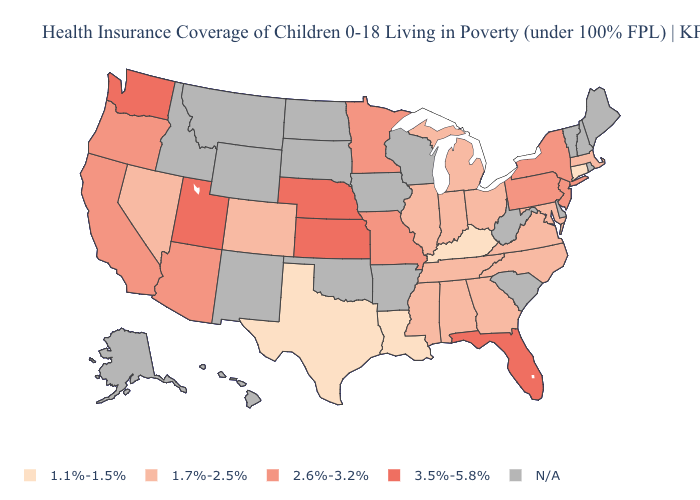Does Texas have the highest value in the USA?
Give a very brief answer. No. Does the map have missing data?
Concise answer only. Yes. Name the states that have a value in the range 3.5%-5.8%?
Quick response, please. Florida, Kansas, Nebraska, Utah, Washington. What is the value of Connecticut?
Quick response, please. 1.1%-1.5%. Does the first symbol in the legend represent the smallest category?
Short answer required. Yes. What is the value of Nevada?
Concise answer only. 1.7%-2.5%. Does Massachusetts have the lowest value in the USA?
Short answer required. No. What is the value of Colorado?
Concise answer only. 1.7%-2.5%. Name the states that have a value in the range 3.5%-5.8%?
Give a very brief answer. Florida, Kansas, Nebraska, Utah, Washington. Does Arizona have the lowest value in the USA?
Be succinct. No. What is the lowest value in the USA?
Short answer required. 1.1%-1.5%. Does New York have the highest value in the Northeast?
Write a very short answer. Yes. Name the states that have a value in the range 2.6%-3.2%?
Answer briefly. Arizona, California, Minnesota, Missouri, New Jersey, New York, Oregon, Pennsylvania. What is the value of Missouri?
Answer briefly. 2.6%-3.2%. 